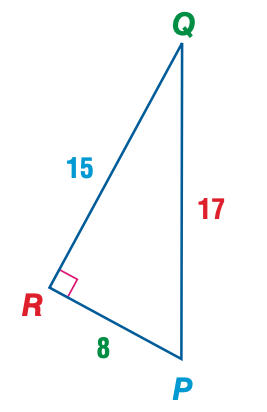Answer the mathemtical geometry problem and directly provide the correct option letter.
Question: Express the ratio of \tan P as a decimal to the nearest hundredth.
Choices: A: 0.47 B: 0.53 C: 0.88 D: 1.88 D 